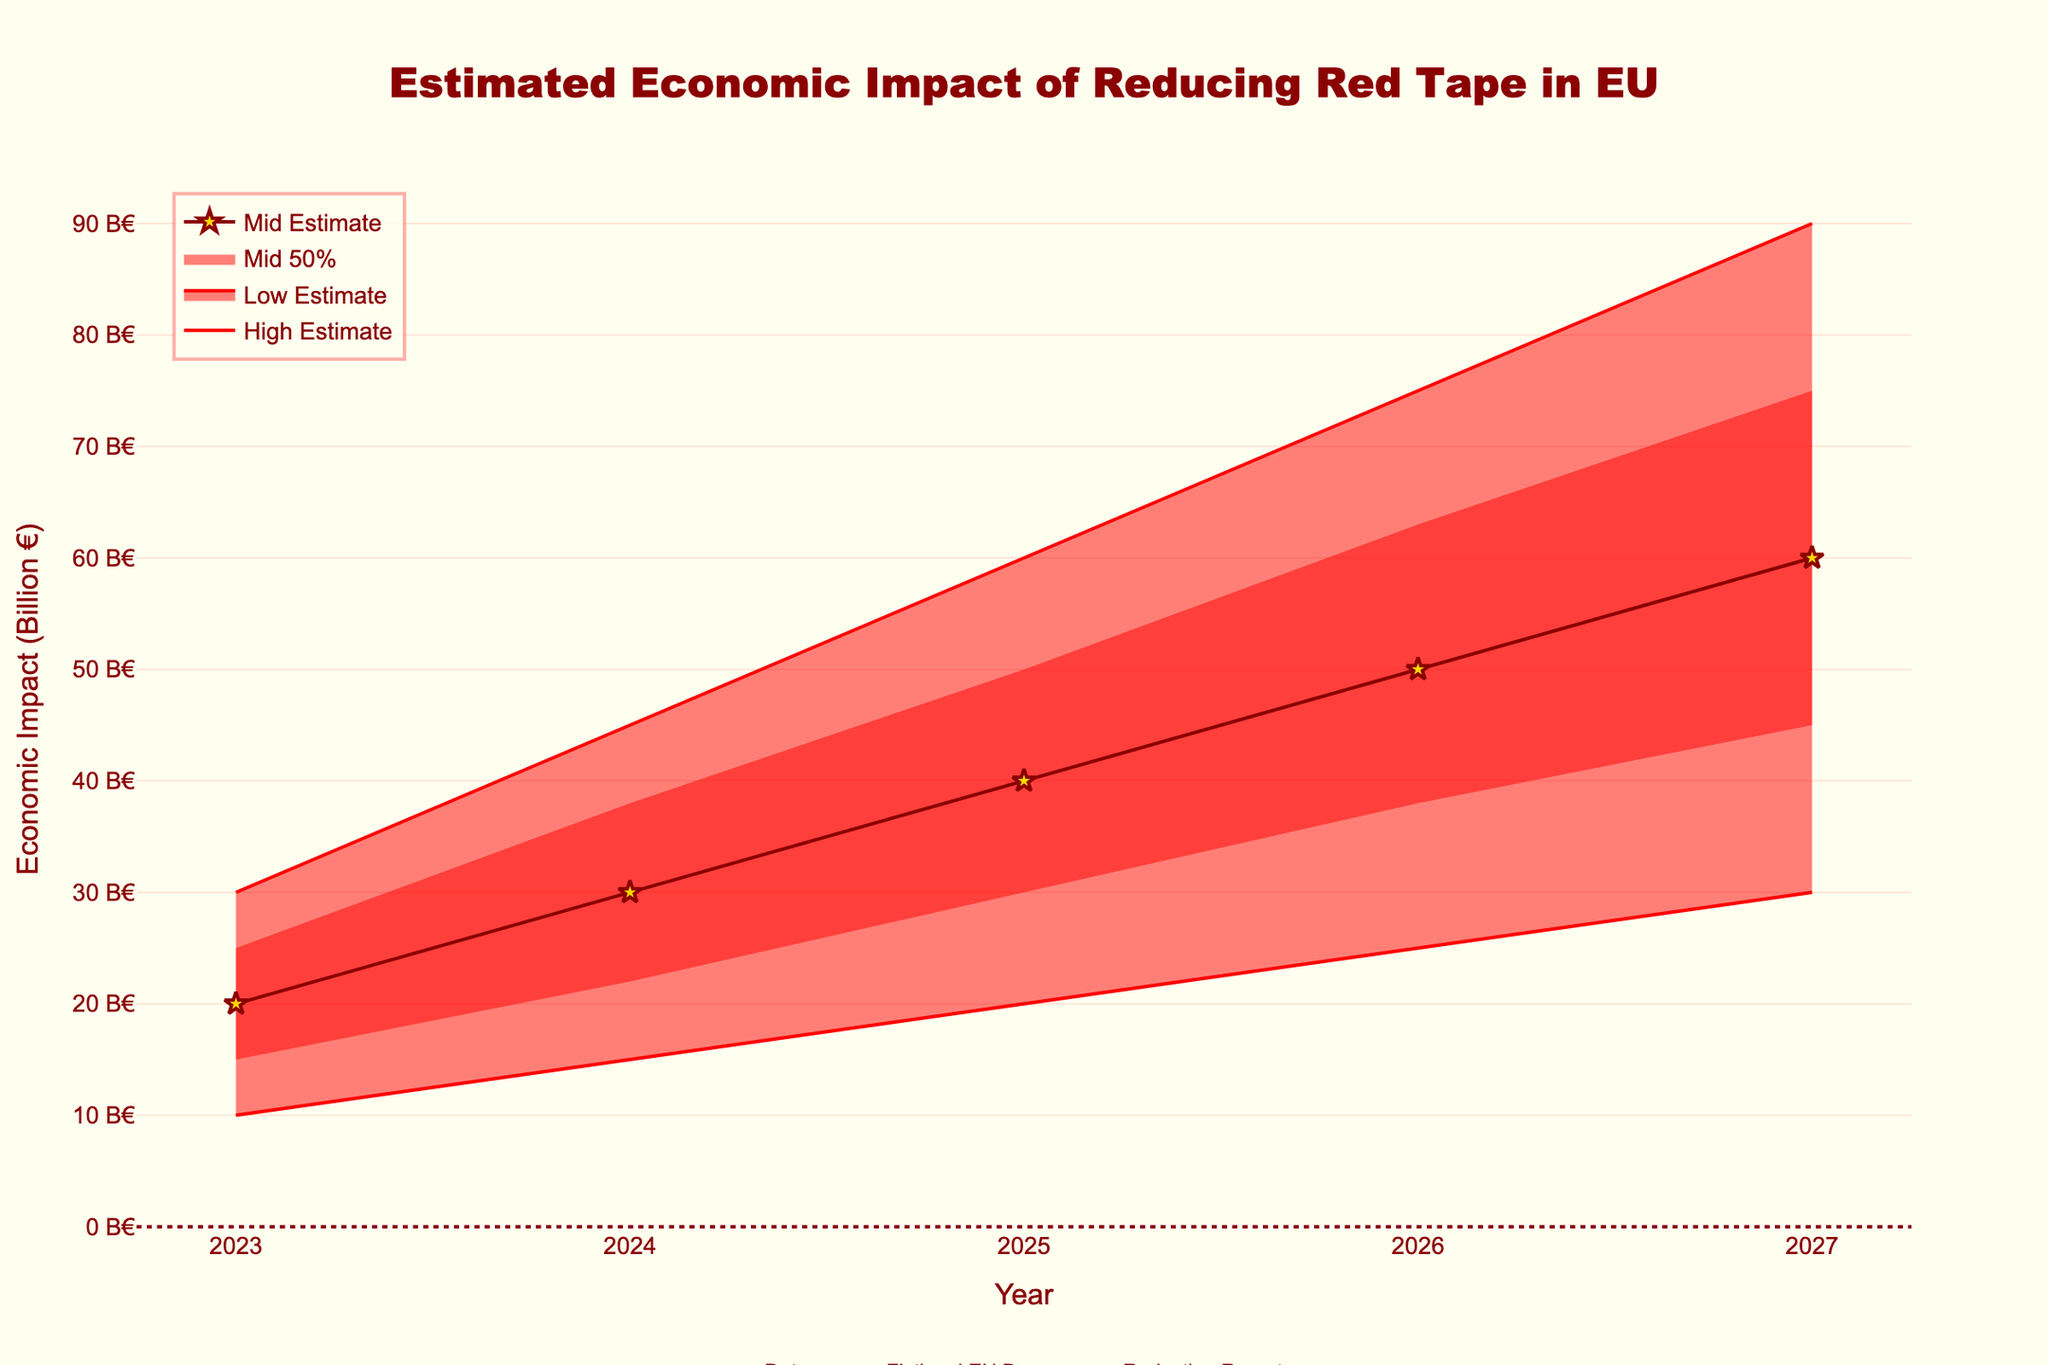What is the title of the chart? The title of the chart is placed at the top center of the figure and reads "Estimated Economic Impact of Reducing Red Tape in EU".
Answer: Estimated Economic Impact of Reducing Red Tape in EU What is the economic impact in 2025 according to the Mid Estimate? The Mid Estimate for 2025 is represented by the gold star markers on the chart, which correspond to a value of 40 billion €.
Answer: 40 billion € In which year is the High Estimate projected to reach 90 billion €? By following the "High Estimate" line, we can see it intersects the y-axis at 90 billion € in the year 2027.
Answer: 2027 How much is the difference between the High-Mid Estimate and Low-Mid Estimate for the year 2024? The High-Mid Estimate value for 2024 is 38 billion €, and the Low-Mid Estimate value for the same year is 22 billion €. The difference is calculated as 38 - 22.
Answer: 16 billion € What is the economic impact range in 2026? The economic impact range in 2026 is defined by the lowest and highest estimates for that year. The Low Estimate is 25 billion € and the High Estimate is 75 billion €, creating a range from 25 to 75 billion €.
Answer: 25 to 75 billion € Between 2024 and 2025, which year has a higher economic impact according to the Low-Mid Estimate? By comparing the values on the Low-Mid Estimate line, 2024 has an economic impact of 22 billion €, and 2025 has an economic impact of 30 billion €.
Answer: 2025 What is the average of Mid Estimates over the 5-year period? Add the Mid Estimates for each year (20, 30, 40, 50, 60) and divide by the number of years (5). The calculation is (20 + 30 + 40 + 50 + 60) / 5.
Answer: 40 billion € Explain the trend of the Mid Estimate economic impact over the next 5 years. The Mid Estimate economic impact is shown by the dark red line with gold star markers. Observing the line, we see a consistent upward trend from 20 billion € in 2023 to 60 billion € in 2027, indicating a steady increase each year.
Answer: Steady increase Which estimate category has the widest uncertainty range in 2023? The uncertainty range is calculated as the difference between the High Estimate and the Low Estimate. In 2023, the range is from 30 billion € (High Estimate) to 10 billion € (Low Estimate), making it the widest uncertainty range.
Answer: High Estimate 